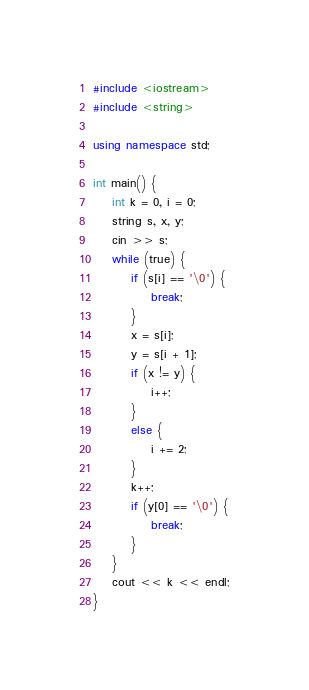Convert code to text. <code><loc_0><loc_0><loc_500><loc_500><_C++_>#include <iostream>
#include <string>

using namespace std;

int main() {
	int k = 0, i = 0;
	string s, x, y;
	cin >> s;
	while (true) {
		if (s[i] == '\0') {
			break;
		}
		x = s[i];
		y = s[i + 1];
		if (x != y) {
			i++;
		}
		else {
			i += 2;
		}
		k++;
		if (y[0] == '\0') {
			break;
		}
	}
	cout << k << endl;
}</code> 